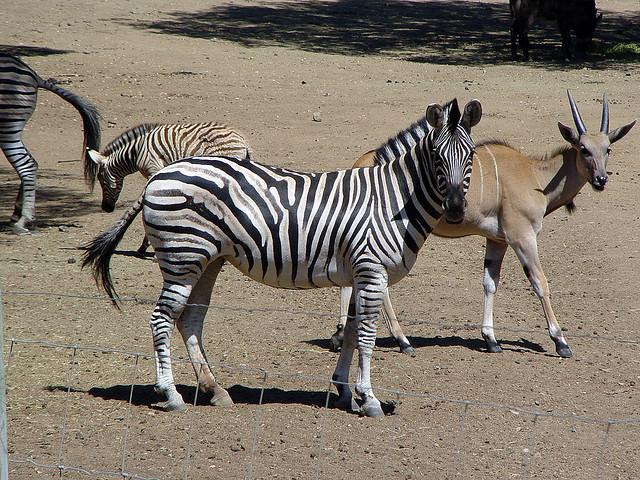What animal is not a zebra?
Be succinct. Gazelle. Where is the antelope?
Keep it brief. Behind zebra. Where are the animals looking?
Write a very short answer. Camera. What kind of animal is this?
Be succinct. Zebra. Is there a goat in the photo?
Short answer required. No. 